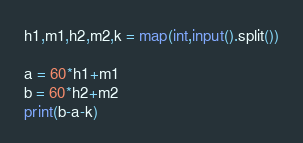Convert code to text. <code><loc_0><loc_0><loc_500><loc_500><_Python_>h1,m1,h2,m2,k = map(int,input().split())

a = 60*h1+m1
b = 60*h2+m2
print(b-a-k)</code> 